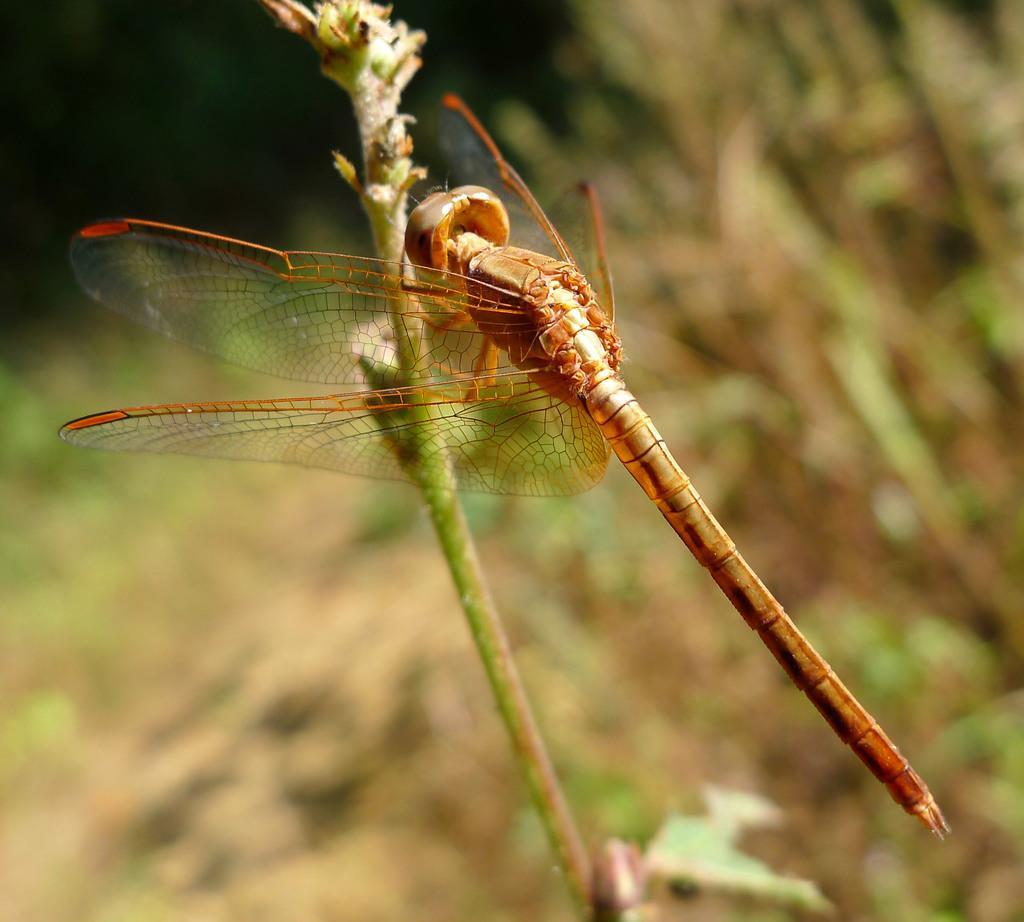How would you summarize this image in a sentence or two? In this image I can see a insect which is gold and brown in color on a plant which is green in color. In the background I can see few blurry objects which are brown, green and black in color. 